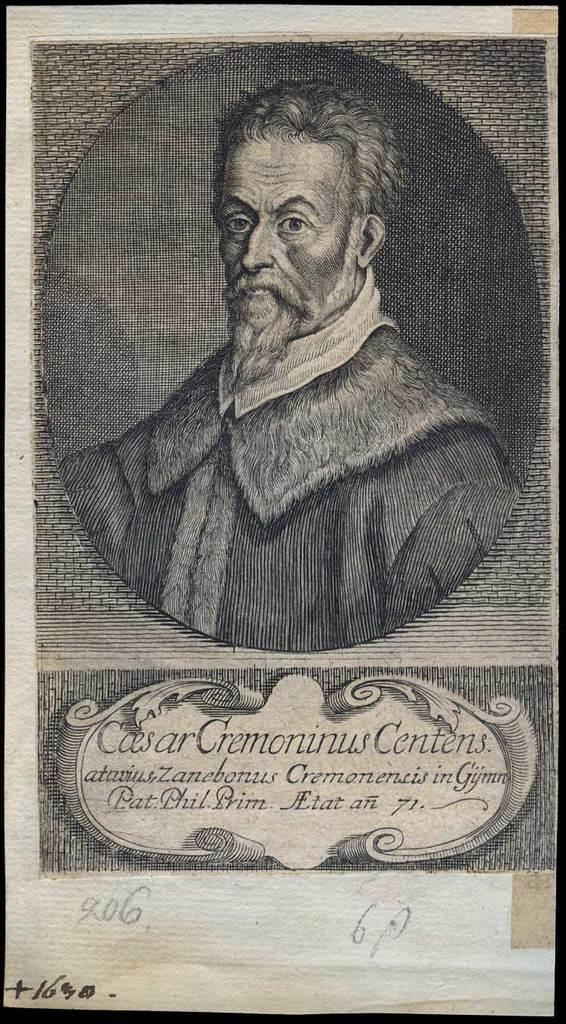Who or what is depicted on the poster? There is a person on the poster. What else can be seen on the poster besides the person? There is text written on the poster. Is there any numerical information on the poster? Yes, there is a number written on the poster. What breed of dog is featured on the poster? There is no dog present on the poster; it features a person, text, and a number. 